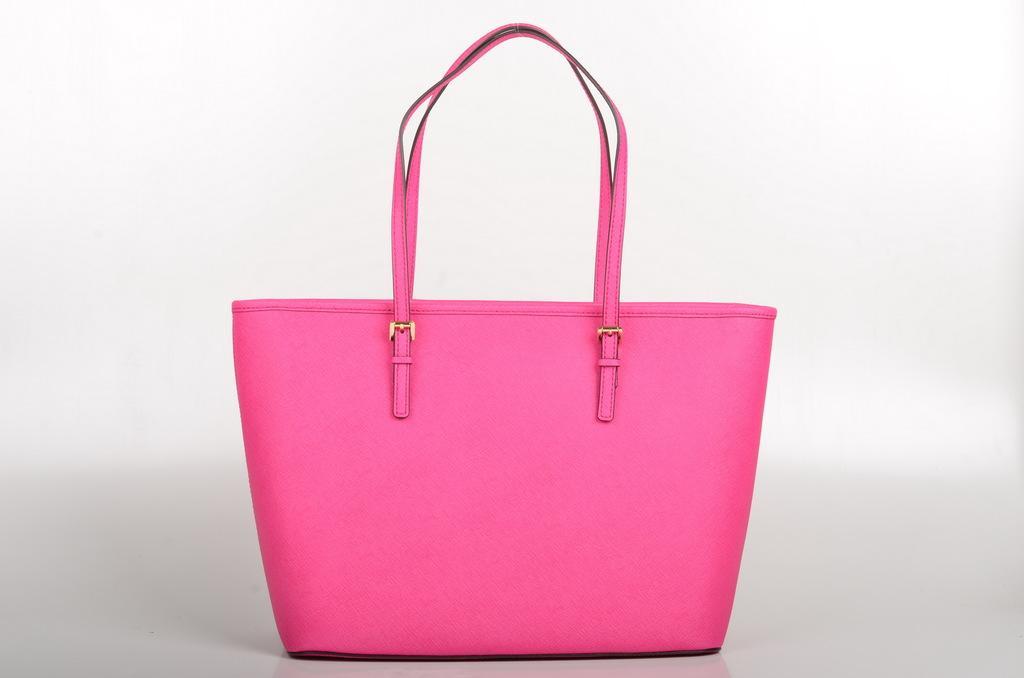How would you summarize this image in a sentence or two? In this picture we can see a pink color bag. 